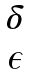Convert formula to latex. <formula><loc_0><loc_0><loc_500><loc_500>\begin{matrix} \delta \\ \epsilon \end{matrix}</formula> 